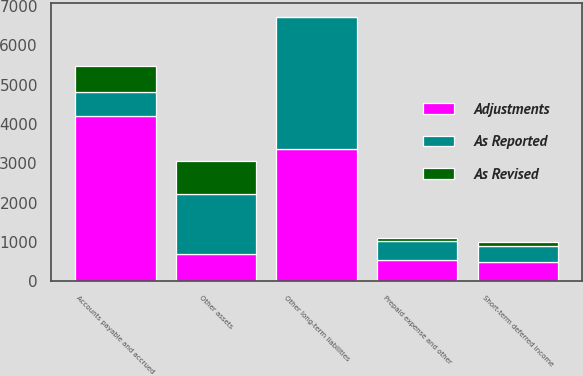Convert chart. <chart><loc_0><loc_0><loc_500><loc_500><stacked_bar_chart><ecel><fcel>Short-term deferred income<fcel>Prepaid expense and other<fcel>Other assets<fcel>Accounts payable and accrued<fcel>Other long-term liabilities<nl><fcel>As Reported<fcel>393<fcel>468<fcel>1534<fcel>603<fcel>3351<nl><fcel>As Revised<fcel>111<fcel>80<fcel>836<fcel>658<fcel>13<nl><fcel>Adjustments<fcel>504<fcel>548<fcel>698<fcel>4208<fcel>3364<nl></chart> 